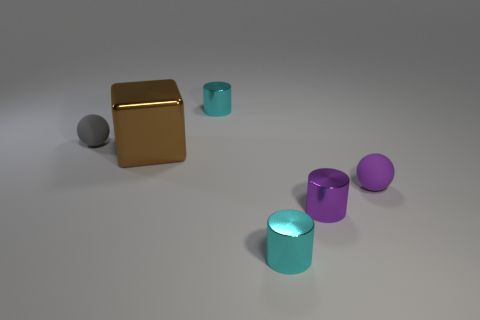Add 1 tiny cyan cylinders. How many objects exist? 7 Subtract all spheres. How many objects are left? 4 Add 4 metallic things. How many metallic things are left? 8 Add 2 tiny gray things. How many tiny gray things exist? 3 Subtract 0 brown spheres. How many objects are left? 6 Subtract all big brown matte balls. Subtract all tiny purple rubber balls. How many objects are left? 5 